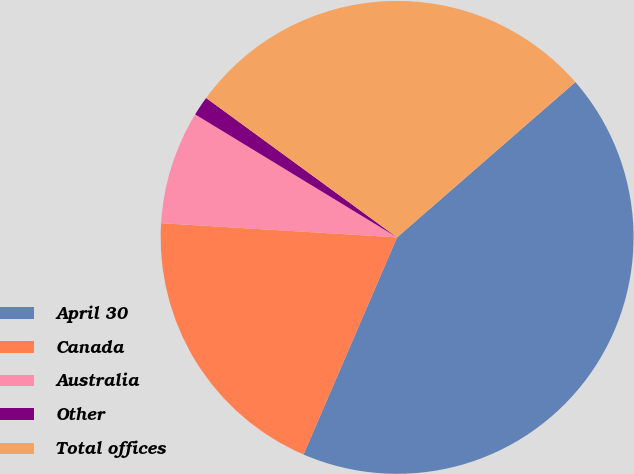Convert chart to OTSL. <chart><loc_0><loc_0><loc_500><loc_500><pie_chart><fcel>April 30<fcel>Canada<fcel>Australia<fcel>Other<fcel>Total offices<nl><fcel>42.88%<fcel>19.48%<fcel>7.75%<fcel>1.33%<fcel>28.56%<nl></chart> 